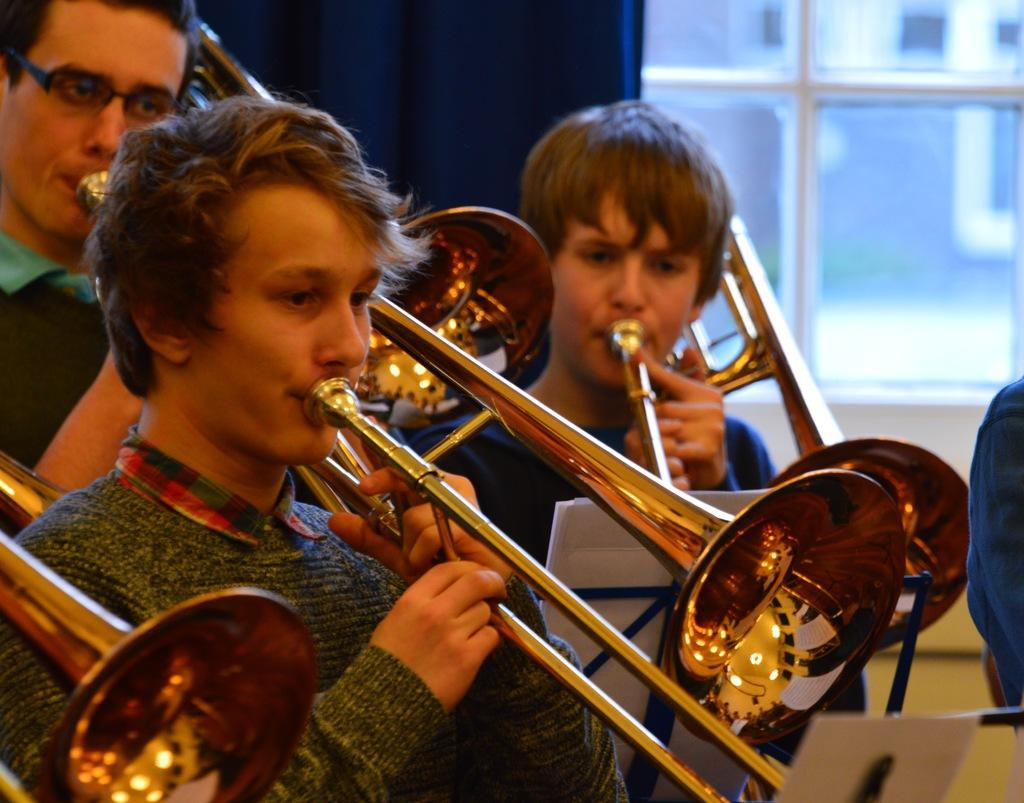Where was the image taken? The image was taken indoors. What are the people in the foreground doing? The people are standing and playing trombones. Can you describe the background of the image? There is a window in the background, and a blue curtain is associated with the window. Can you see any baseball players in the image? There are no baseball players present in the image. Is there a goat visible in the image? There is no goat present in the image. 